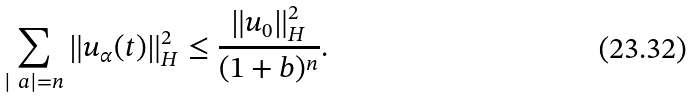Convert formula to latex. <formula><loc_0><loc_0><loc_500><loc_500>\sum _ { | \ a | = n } \| u _ { \alpha } ( t ) \| _ { H } ^ { 2 } \leq \frac { \| u _ { 0 } \| _ { H } ^ { 2 } } { ( 1 + b ) ^ { n } } .</formula> 